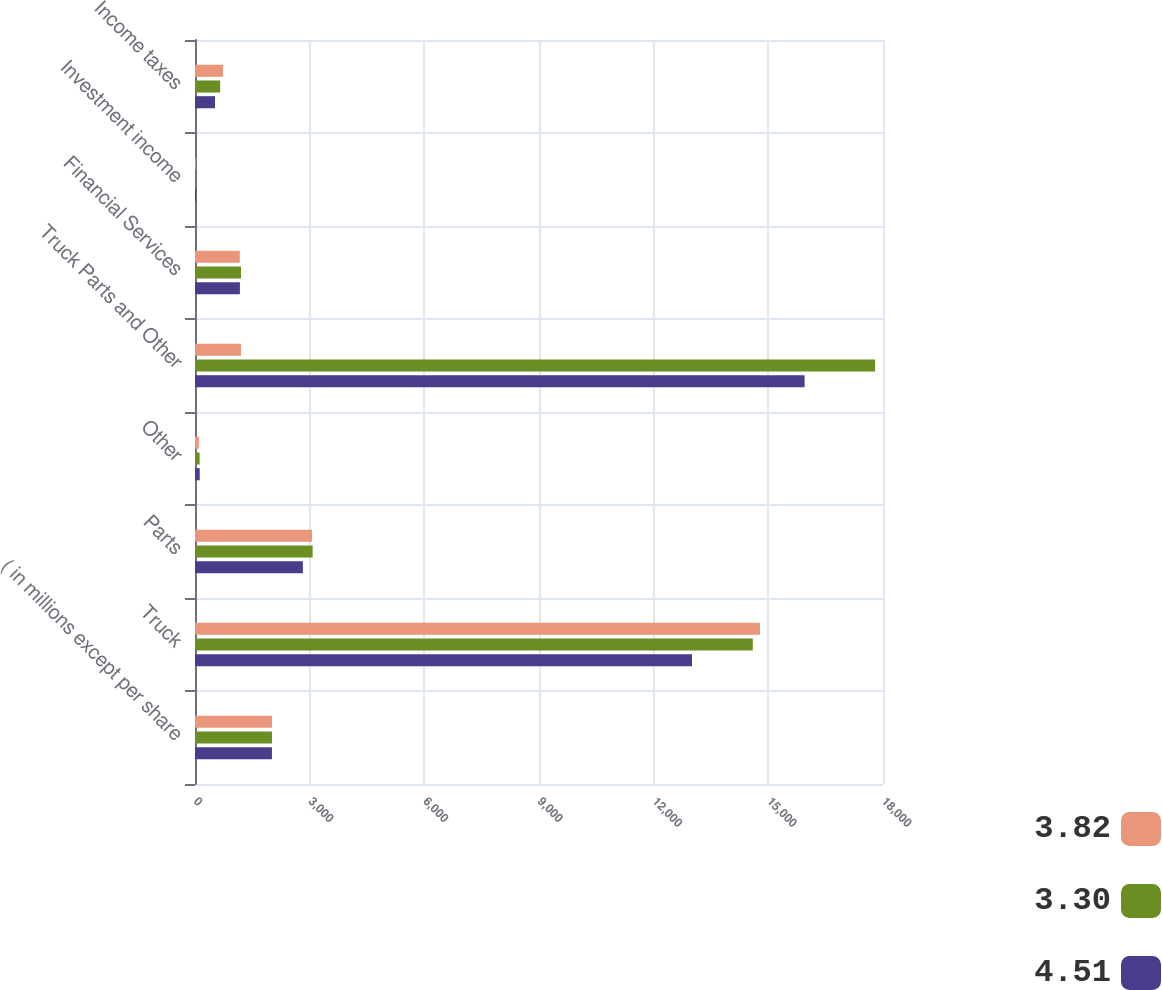<chart> <loc_0><loc_0><loc_500><loc_500><stacked_bar_chart><ecel><fcel>( in millions except per share<fcel>Truck<fcel>Parts<fcel>Other<fcel>Truck Parts and Other<fcel>Financial Services<fcel>Investment income<fcel>Income taxes<nl><fcel>3.82<fcel>2015<fcel>14782.5<fcel>3060.1<fcel>100.2<fcel>1204.2<fcel>1172.3<fcel>21.8<fcel>733.1<nl><fcel>3.3<fcel>2014<fcel>14594<fcel>3077.5<fcel>121.3<fcel>17792.8<fcel>1204.2<fcel>22.3<fcel>658.8<nl><fcel>4.51<fcel>2013<fcel>13002.9<fcel>2822.2<fcel>123.8<fcel>15948.9<fcel>1174.9<fcel>28.6<fcel>523.7<nl></chart> 